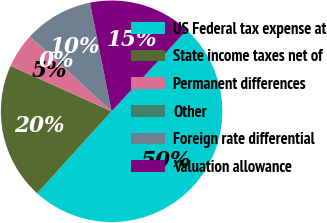Convert chart to OTSL. <chart><loc_0><loc_0><loc_500><loc_500><pie_chart><fcel>US Federal tax expense at<fcel>State income taxes net of<fcel>Permanent differences<fcel>Other<fcel>Foreign rate differential<fcel>Valuation allowance<nl><fcel>49.87%<fcel>19.99%<fcel>5.05%<fcel>0.07%<fcel>10.03%<fcel>15.01%<nl></chart> 